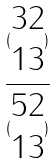<formula> <loc_0><loc_0><loc_500><loc_500>\frac { ( \begin{matrix} 3 2 \\ 1 3 \end{matrix} ) } { ( \begin{matrix} 5 2 \\ 1 3 \end{matrix} ) }</formula> 